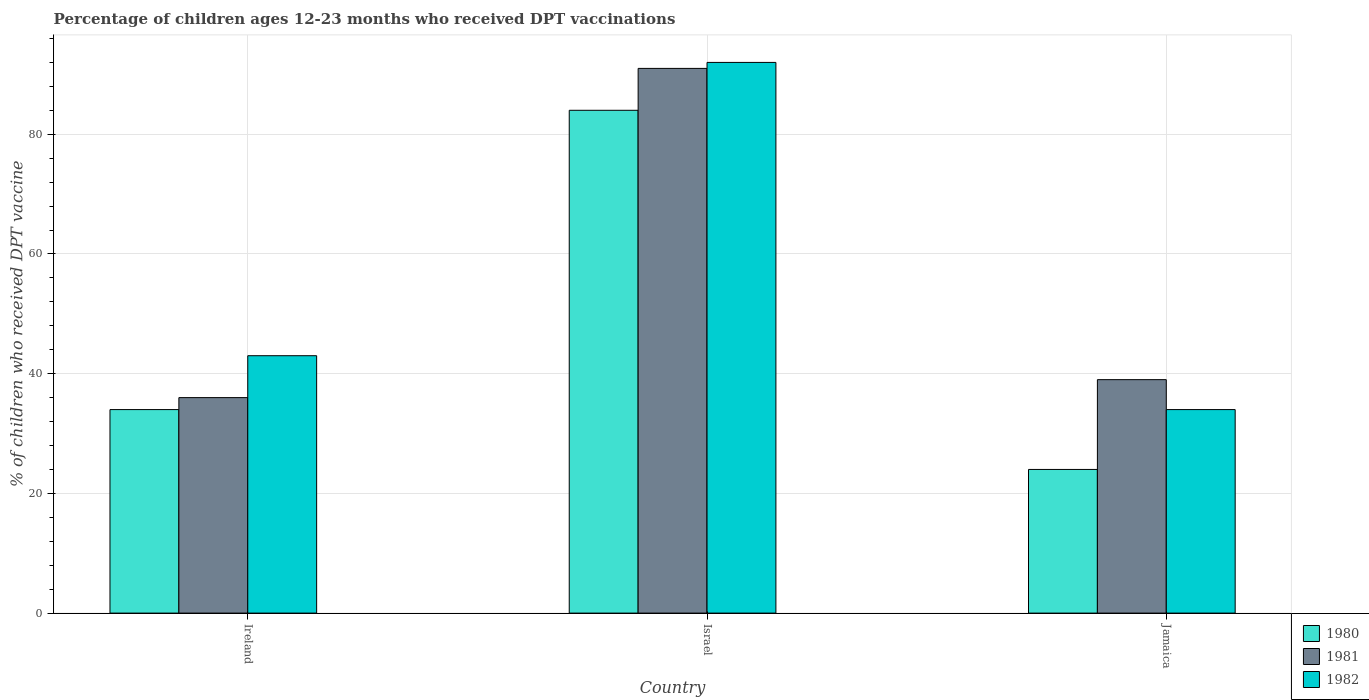How many different coloured bars are there?
Offer a very short reply. 3. Are the number of bars per tick equal to the number of legend labels?
Offer a very short reply. Yes. What is the label of the 1st group of bars from the left?
Offer a terse response. Ireland. In how many cases, is the number of bars for a given country not equal to the number of legend labels?
Provide a short and direct response. 0. Across all countries, what is the maximum percentage of children who received DPT vaccination in 1982?
Offer a terse response. 92. In which country was the percentage of children who received DPT vaccination in 1981 minimum?
Make the answer very short. Ireland. What is the total percentage of children who received DPT vaccination in 1981 in the graph?
Your answer should be compact. 166. What is the difference between the percentage of children who received DPT vaccination in 1982 in Ireland and that in Jamaica?
Offer a terse response. 9. What is the difference between the percentage of children who received DPT vaccination in 1981 in Israel and the percentage of children who received DPT vaccination in 1980 in Jamaica?
Provide a succinct answer. 67. What is the average percentage of children who received DPT vaccination in 1981 per country?
Keep it short and to the point. 55.33. In how many countries, is the percentage of children who received DPT vaccination in 1981 greater than 68 %?
Your answer should be very brief. 1. What is the ratio of the percentage of children who received DPT vaccination in 1980 in Ireland to that in Israel?
Your response must be concise. 0.4. What is the difference between the highest and the lowest percentage of children who received DPT vaccination in 1982?
Ensure brevity in your answer.  58. Is the sum of the percentage of children who received DPT vaccination in 1982 in Israel and Jamaica greater than the maximum percentage of children who received DPT vaccination in 1980 across all countries?
Your response must be concise. Yes. What does the 3rd bar from the left in Israel represents?
Provide a succinct answer. 1982. What does the 2nd bar from the right in Israel represents?
Offer a terse response. 1981. How many bars are there?
Your response must be concise. 9. Where does the legend appear in the graph?
Provide a short and direct response. Bottom right. How many legend labels are there?
Your response must be concise. 3. How are the legend labels stacked?
Make the answer very short. Vertical. What is the title of the graph?
Give a very brief answer. Percentage of children ages 12-23 months who received DPT vaccinations. Does "1965" appear as one of the legend labels in the graph?
Give a very brief answer. No. What is the label or title of the X-axis?
Your response must be concise. Country. What is the label or title of the Y-axis?
Keep it short and to the point. % of children who received DPT vaccine. What is the % of children who received DPT vaccine of 1980 in Ireland?
Your answer should be very brief. 34. What is the % of children who received DPT vaccine in 1981 in Ireland?
Your response must be concise. 36. What is the % of children who received DPT vaccine in 1982 in Ireland?
Make the answer very short. 43. What is the % of children who received DPT vaccine of 1980 in Israel?
Keep it short and to the point. 84. What is the % of children who received DPT vaccine in 1981 in Israel?
Your answer should be very brief. 91. What is the % of children who received DPT vaccine of 1982 in Israel?
Offer a very short reply. 92. What is the % of children who received DPT vaccine of 1980 in Jamaica?
Provide a short and direct response. 24. Across all countries, what is the maximum % of children who received DPT vaccine of 1980?
Provide a succinct answer. 84. Across all countries, what is the maximum % of children who received DPT vaccine of 1981?
Provide a succinct answer. 91. Across all countries, what is the maximum % of children who received DPT vaccine of 1982?
Your answer should be compact. 92. Across all countries, what is the minimum % of children who received DPT vaccine in 1981?
Offer a terse response. 36. Across all countries, what is the minimum % of children who received DPT vaccine in 1982?
Give a very brief answer. 34. What is the total % of children who received DPT vaccine of 1980 in the graph?
Ensure brevity in your answer.  142. What is the total % of children who received DPT vaccine in 1981 in the graph?
Keep it short and to the point. 166. What is the total % of children who received DPT vaccine of 1982 in the graph?
Provide a succinct answer. 169. What is the difference between the % of children who received DPT vaccine of 1980 in Ireland and that in Israel?
Keep it short and to the point. -50. What is the difference between the % of children who received DPT vaccine in 1981 in Ireland and that in Israel?
Offer a terse response. -55. What is the difference between the % of children who received DPT vaccine in 1982 in Ireland and that in Israel?
Provide a succinct answer. -49. What is the difference between the % of children who received DPT vaccine in 1981 in Israel and that in Jamaica?
Give a very brief answer. 52. What is the difference between the % of children who received DPT vaccine in 1982 in Israel and that in Jamaica?
Your answer should be compact. 58. What is the difference between the % of children who received DPT vaccine of 1980 in Ireland and the % of children who received DPT vaccine of 1981 in Israel?
Offer a terse response. -57. What is the difference between the % of children who received DPT vaccine in 1980 in Ireland and the % of children who received DPT vaccine in 1982 in Israel?
Offer a very short reply. -58. What is the difference between the % of children who received DPT vaccine in 1981 in Ireland and the % of children who received DPT vaccine in 1982 in Israel?
Your response must be concise. -56. What is the difference between the % of children who received DPT vaccine in 1980 in Israel and the % of children who received DPT vaccine in 1982 in Jamaica?
Your answer should be very brief. 50. What is the average % of children who received DPT vaccine in 1980 per country?
Provide a short and direct response. 47.33. What is the average % of children who received DPT vaccine of 1981 per country?
Provide a short and direct response. 55.33. What is the average % of children who received DPT vaccine in 1982 per country?
Your response must be concise. 56.33. What is the difference between the % of children who received DPT vaccine of 1980 and % of children who received DPT vaccine of 1981 in Ireland?
Give a very brief answer. -2. What is the difference between the % of children who received DPT vaccine in 1980 and % of children who received DPT vaccine in 1981 in Israel?
Keep it short and to the point. -7. What is the difference between the % of children who received DPT vaccine in 1981 and % of children who received DPT vaccine in 1982 in Jamaica?
Your answer should be compact. 5. What is the ratio of the % of children who received DPT vaccine in 1980 in Ireland to that in Israel?
Make the answer very short. 0.4. What is the ratio of the % of children who received DPT vaccine in 1981 in Ireland to that in Israel?
Your answer should be compact. 0.4. What is the ratio of the % of children who received DPT vaccine in 1982 in Ireland to that in Israel?
Offer a terse response. 0.47. What is the ratio of the % of children who received DPT vaccine in 1980 in Ireland to that in Jamaica?
Provide a succinct answer. 1.42. What is the ratio of the % of children who received DPT vaccine in 1982 in Ireland to that in Jamaica?
Offer a very short reply. 1.26. What is the ratio of the % of children who received DPT vaccine in 1980 in Israel to that in Jamaica?
Offer a very short reply. 3.5. What is the ratio of the % of children who received DPT vaccine of 1981 in Israel to that in Jamaica?
Keep it short and to the point. 2.33. What is the ratio of the % of children who received DPT vaccine in 1982 in Israel to that in Jamaica?
Provide a succinct answer. 2.71. What is the difference between the highest and the second highest % of children who received DPT vaccine in 1980?
Ensure brevity in your answer.  50. What is the difference between the highest and the second highest % of children who received DPT vaccine in 1982?
Give a very brief answer. 49. What is the difference between the highest and the lowest % of children who received DPT vaccine of 1981?
Provide a short and direct response. 55. What is the difference between the highest and the lowest % of children who received DPT vaccine of 1982?
Your response must be concise. 58. 